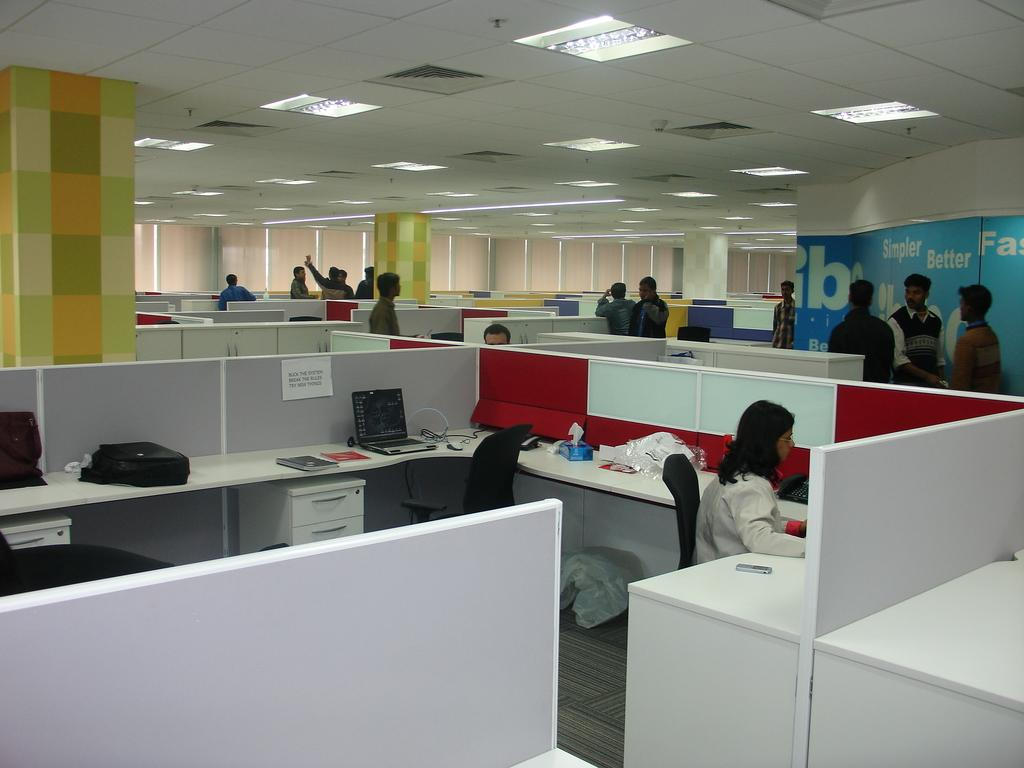How many people are in the room? There are people in the room, but the exact number is not specified. What is the woman doing in the image? The woman is sitting beside a table. What electronic device is on the table? There is a laptop on the table. What else is on the table besides the laptop? There is a bag and other unspecified objects on the table. What type of substance is the owl made of in the image? There is no owl present in the image, so it is not possible to determine what substance it might be made of. 